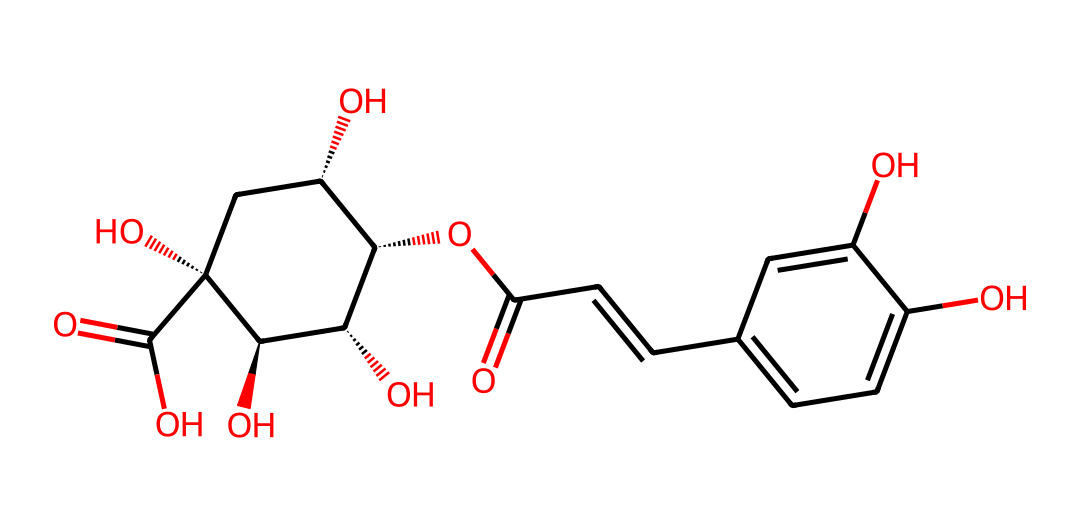What is the molecular formula of chlorogenic acid? To find the molecular formula, count the number of each type of atom in the SMILES. The breakdown shows 18 carbon atoms, 18 hydrogen atoms, and 9 oxygen atoms, leading to the formula C18H18O9.
Answer: C18H18O9 How many hydroxyl groups are present in this structure? By examining the structure, note the -OH groups. In the SMILES, there are two occurrences of hydroxyl (indicated by "O" followed by a carbon). Thus, there are two hydroxyl groups.
Answer: 2 What functional groups are represented in chlorogenic acid? Analyze the SMILES to identify specific parts of the structure. The presence of -OH groups indicates phenolic functional groups, and the carbonyl group (C=O) indicates a ketone or aldehyde functional group. Therefore, both phenolic and carbonyl groups are present.
Answer: phenolic and carbonyl How many rings are in the molecular structure of chlorogenic acid? Count the distinct cycles in the structure. The presence of another ring structure can be noted through the cyclic references. The structure contains one cyclic aliphatic system, so there are no neat rings beyond the single cycle indicated.
Answer: 1 Which part of chlorogenic acid contributes to its antioxidant properties? Recognize that phenolic compounds are known for their antioxidant capacity. The phenolic hydroxyl groups are acknowledged contributors to this property, granting the molecular structure its antioxidant qualities.
Answer: phenolic hydroxyl groups What type of chemical is chlorogenic acid classified as? Review the features of the chemical structure. Given its phenolic components, chlorogenic acid is classified as a polyphenol, indicative of its multiple benzene rings and hydroxyl groups.
Answer: polyphenol 